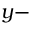Convert formula to latex. <formula><loc_0><loc_0><loc_500><loc_500>y -</formula> 